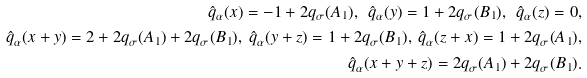<formula> <loc_0><loc_0><loc_500><loc_500>\hat { q } _ { \alpha } ( x ) = - 1 + 2 q _ { \sigma } ( A _ { 1 } ) , \ \hat { q } _ { \alpha } ( y ) = 1 + 2 q _ { \sigma } ( B _ { 1 } ) , \ \hat { q } _ { \alpha } ( z ) = 0 , \\ \hat { q } _ { \alpha } ( x + y ) = 2 + 2 q _ { \sigma } ( A _ { 1 } ) + 2 q _ { \sigma } ( B _ { 1 } ) , \ \hat { q } _ { \alpha } ( y + z ) = 1 + 2 q _ { \sigma } ( B _ { 1 } ) , \ \hat { q } _ { \alpha } ( z + x ) = 1 + 2 q _ { \sigma } ( A _ { 1 } ) , \\ \hat { q } _ { \alpha } ( x + y + z ) = 2 q _ { \sigma } ( A _ { 1 } ) + 2 q _ { \sigma } ( B _ { 1 } ) .</formula> 